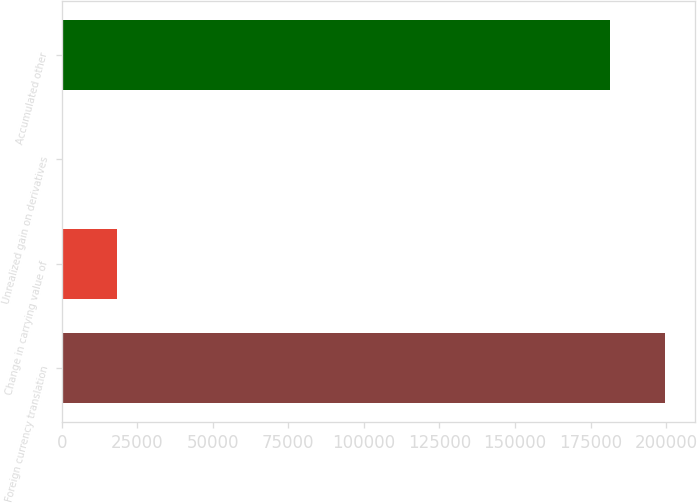<chart> <loc_0><loc_0><loc_500><loc_500><bar_chart><fcel>Foreign currency translation<fcel>Change in carrying value of<fcel>Unrealized gain on derivatives<fcel>Accumulated other<nl><fcel>199653<fcel>18182.4<fcel>11<fcel>181482<nl></chart> 